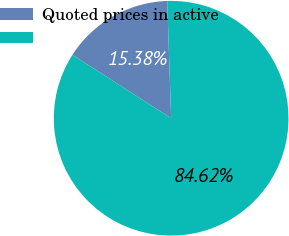Convert chart. <chart><loc_0><loc_0><loc_500><loc_500><pie_chart><fcel>Quoted prices in active<fcel>Unnamed: 1<nl><fcel>15.38%<fcel>84.62%<nl></chart> 